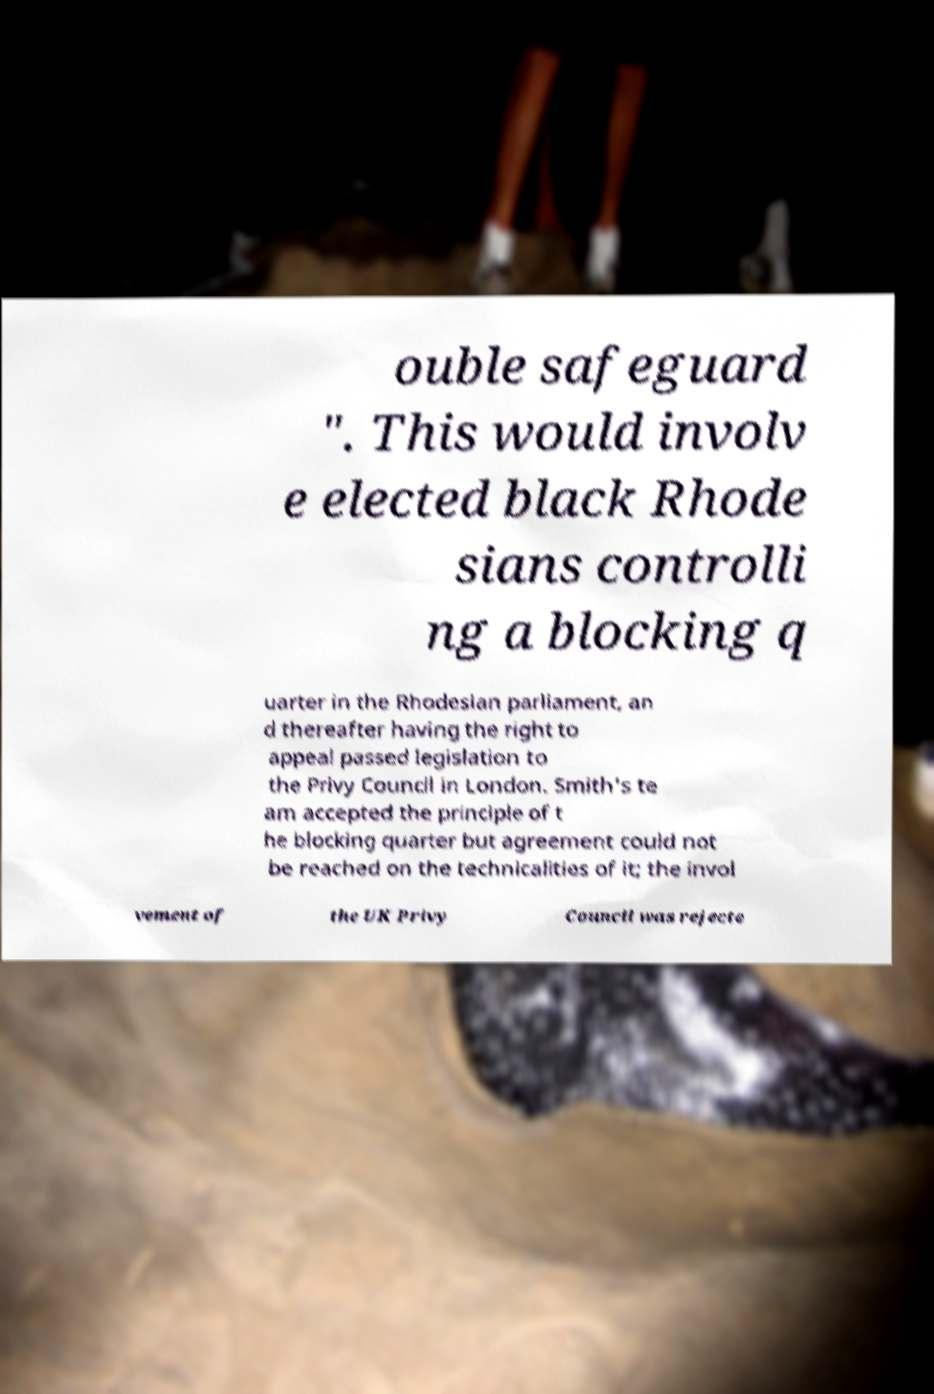For documentation purposes, I need the text within this image transcribed. Could you provide that? ouble safeguard ". This would involv e elected black Rhode sians controlli ng a blocking q uarter in the Rhodesian parliament, an d thereafter having the right to appeal passed legislation to the Privy Council in London. Smith's te am accepted the principle of t he blocking quarter but agreement could not be reached on the technicalities of it; the invol vement of the UK Privy Council was rejecte 